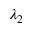Convert formula to latex. <formula><loc_0><loc_0><loc_500><loc_500>\lambda _ { 2 }</formula> 